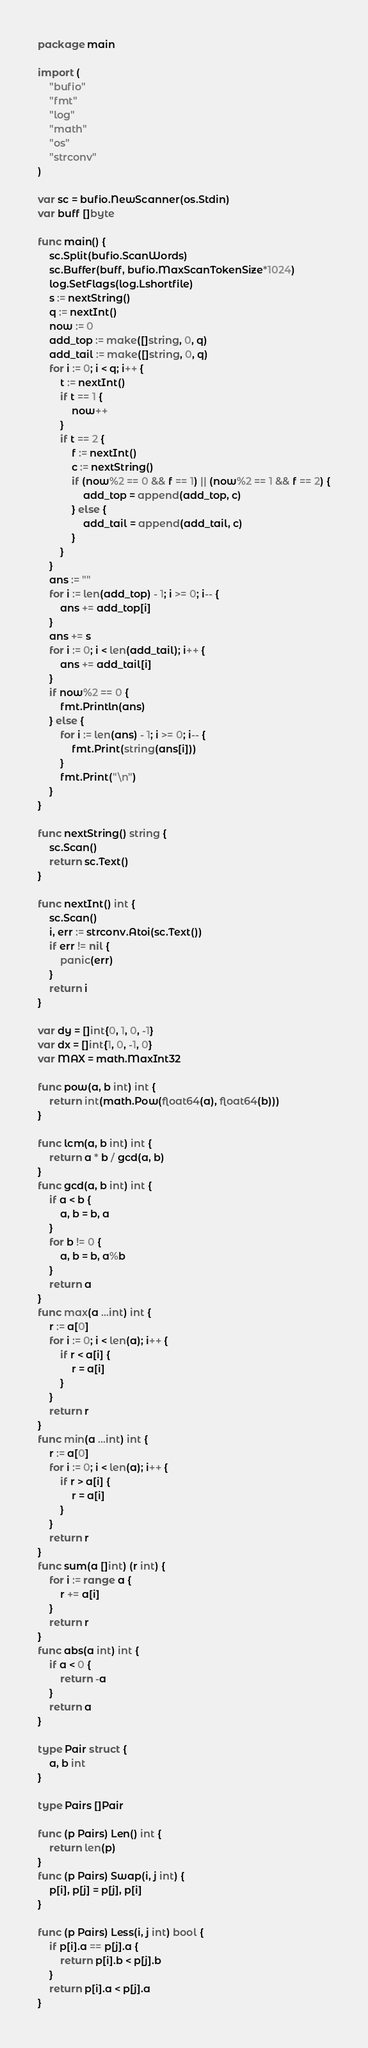Convert code to text. <code><loc_0><loc_0><loc_500><loc_500><_Go_>package main

import (
	"bufio"
	"fmt"
	"log"
	"math"
	"os"
	"strconv"
)

var sc = bufio.NewScanner(os.Stdin)
var buff []byte

func main() {
	sc.Split(bufio.ScanWords)
	sc.Buffer(buff, bufio.MaxScanTokenSize*1024)
	log.SetFlags(log.Lshortfile)
	s := nextString()
	q := nextInt()
	now := 0
	add_top := make([]string, 0, q)
	add_tail := make([]string, 0, q)
	for i := 0; i < q; i++ {
		t := nextInt()
		if t == 1 {
			now++
		}
		if t == 2 {
			f := nextInt()
			c := nextString()
			if (now%2 == 0 && f == 1) || (now%2 == 1 && f == 2) {
				add_top = append(add_top, c)
			} else {
				add_tail = append(add_tail, c)
			}
		}
	}
	ans := ""
	for i := len(add_top) - 1; i >= 0; i-- {
		ans += add_top[i]
	}
	ans += s
	for i := 0; i < len(add_tail); i++ {
		ans += add_tail[i]
	}
	if now%2 == 0 {
		fmt.Println(ans)
	} else {
		for i := len(ans) - 1; i >= 0; i-- {
			fmt.Print(string(ans[i]))
		}
		fmt.Print("\n")
	}
}

func nextString() string {
	sc.Scan()
	return sc.Text()
}

func nextInt() int {
	sc.Scan()
	i, err := strconv.Atoi(sc.Text())
	if err != nil {
		panic(err)
	}
	return i
}

var dy = []int{0, 1, 0, -1}
var dx = []int{1, 0, -1, 0}
var MAX = math.MaxInt32

func pow(a, b int) int {
	return int(math.Pow(float64(a), float64(b)))
}

func lcm(a, b int) int {
	return a * b / gcd(a, b)
}
func gcd(a, b int) int {
	if a < b {
		a, b = b, a
	}
	for b != 0 {
		a, b = b, a%b
	}
	return a
}
func max(a ...int) int {
	r := a[0]
	for i := 0; i < len(a); i++ {
		if r < a[i] {
			r = a[i]
		}
	}
	return r
}
func min(a ...int) int {
	r := a[0]
	for i := 0; i < len(a); i++ {
		if r > a[i] {
			r = a[i]
		}
	}
	return r
}
func sum(a []int) (r int) {
	for i := range a {
		r += a[i]
	}
	return r
}
func abs(a int) int {
	if a < 0 {
		return -a
	}
	return a
}

type Pair struct {
	a, b int
}

type Pairs []Pair

func (p Pairs) Len() int {
	return len(p)
}
func (p Pairs) Swap(i, j int) {
	p[i], p[j] = p[j], p[i]
}

func (p Pairs) Less(i, j int) bool {
	if p[i].a == p[j].a {
		return p[i].b < p[j].b
	}
	return p[i].a < p[j].a
}
</code> 